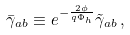Convert formula to latex. <formula><loc_0><loc_0><loc_500><loc_500>\bar { \gamma } _ { a b } \equiv e ^ { - \frac { 2 \phi } { q \Phi _ { h } } } \tilde { \gamma } _ { a b } \, ,</formula> 